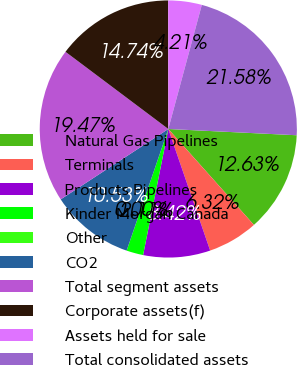Convert chart to OTSL. <chart><loc_0><loc_0><loc_500><loc_500><pie_chart><fcel>Natural Gas Pipelines<fcel>Terminals<fcel>Products Pipelines<fcel>Kinder Morgan Canada<fcel>Other<fcel>CO2<fcel>Total segment assets<fcel>Corporate assets(f)<fcel>Assets held for sale<fcel>Total consolidated assets<nl><fcel>12.63%<fcel>6.32%<fcel>8.42%<fcel>2.11%<fcel>0.0%<fcel>10.53%<fcel>19.47%<fcel>14.74%<fcel>4.21%<fcel>21.58%<nl></chart> 